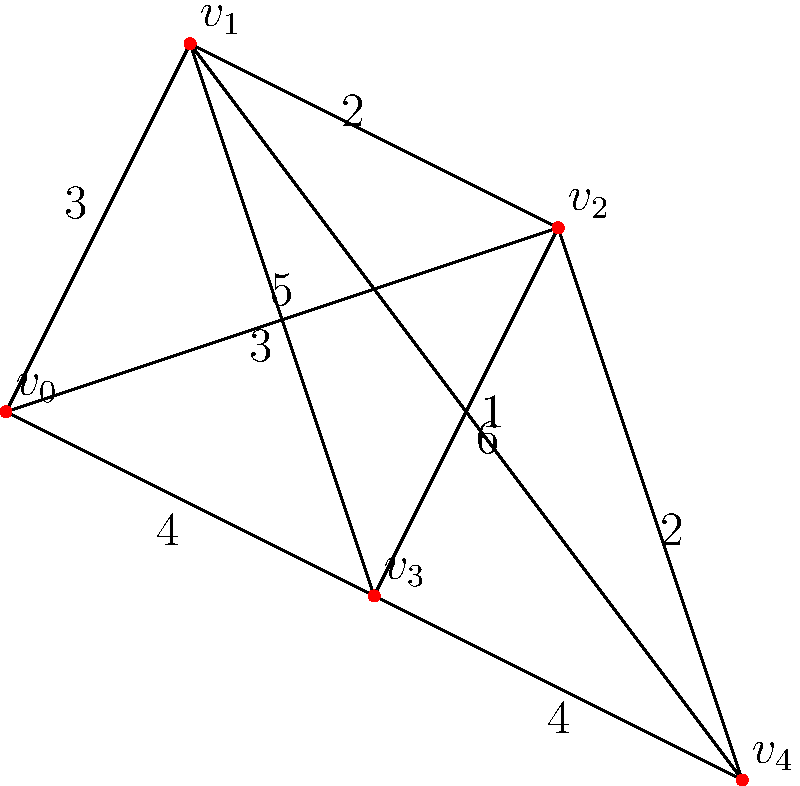In an embroidery design, the vertices represent key points where the needle must pass, and the edges represent the possible paths between these points. The weight of each edge indicates the complexity of the stitch (higher weight means more complex). What is the shortest path from $v_0$ to $v_4$ in terms of total complexity, and what is its total weight? To find the shortest path from $v_0$ to $v_4$, we'll use Dijkstra's algorithm:

1) Initialize distances: $d(v_0) = 0$, all others $\infty$
2) Set $v_0$ as current vertex

3) Update neighbors of $v_0$:
   $d(v_1) = 3$
   $d(v_2) = 5$
   $d(v_3) = 4$

4) Select $v_1$ as new current (closest unvisited)

5) Update neighbors of $v_1$:
   $d(v_2) = \min(5, 3+2) = 5$
   $d(v_3) = \min(4, 3+3) = 4$
   $d(v_4) = 3+6 = 9$

6) Select $v_3$ as new current

7) Update neighbors of $v_3$:
   $d(v_2) = \min(5, 4+1) = 5$
   $d(v_4) = \min(9, 4+4) = 8$

8) Select $v_2$ as new current

9) Update neighbors of $v_2$:
   $d(v_4) = \min(8, 5+2) = 7$

10) Select $v_4$ as new current (all vertices visited)

The shortest path is $v_0 \to v_2 \to v_4$ with total weight 7.
Answer: $v_0 \to v_2 \to v_4$, total weight 7 